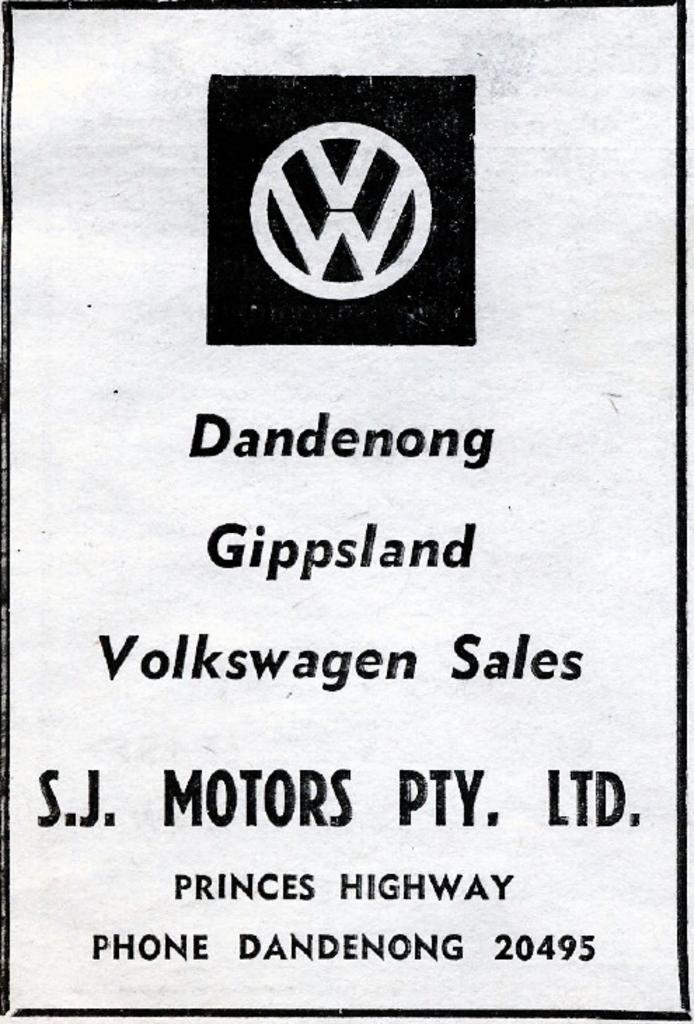<image>
Relay a brief, clear account of the picture shown. A black and white poster for Volkswagen Sales featured in Dandenog Gippsland for SJ Motors PTY LTD 